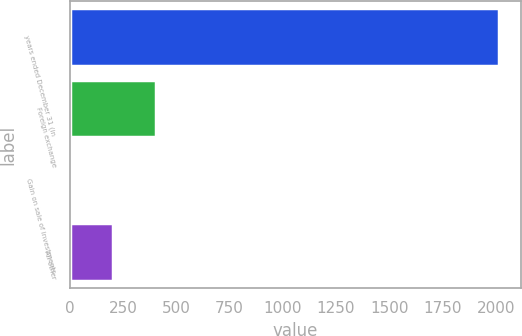<chart> <loc_0><loc_0><loc_500><loc_500><bar_chart><fcel>years ended December 31 (in<fcel>Foreign exchange<fcel>Gain on sale of investments<fcel>All other<nl><fcel>2017<fcel>405.8<fcel>3<fcel>204.4<nl></chart> 